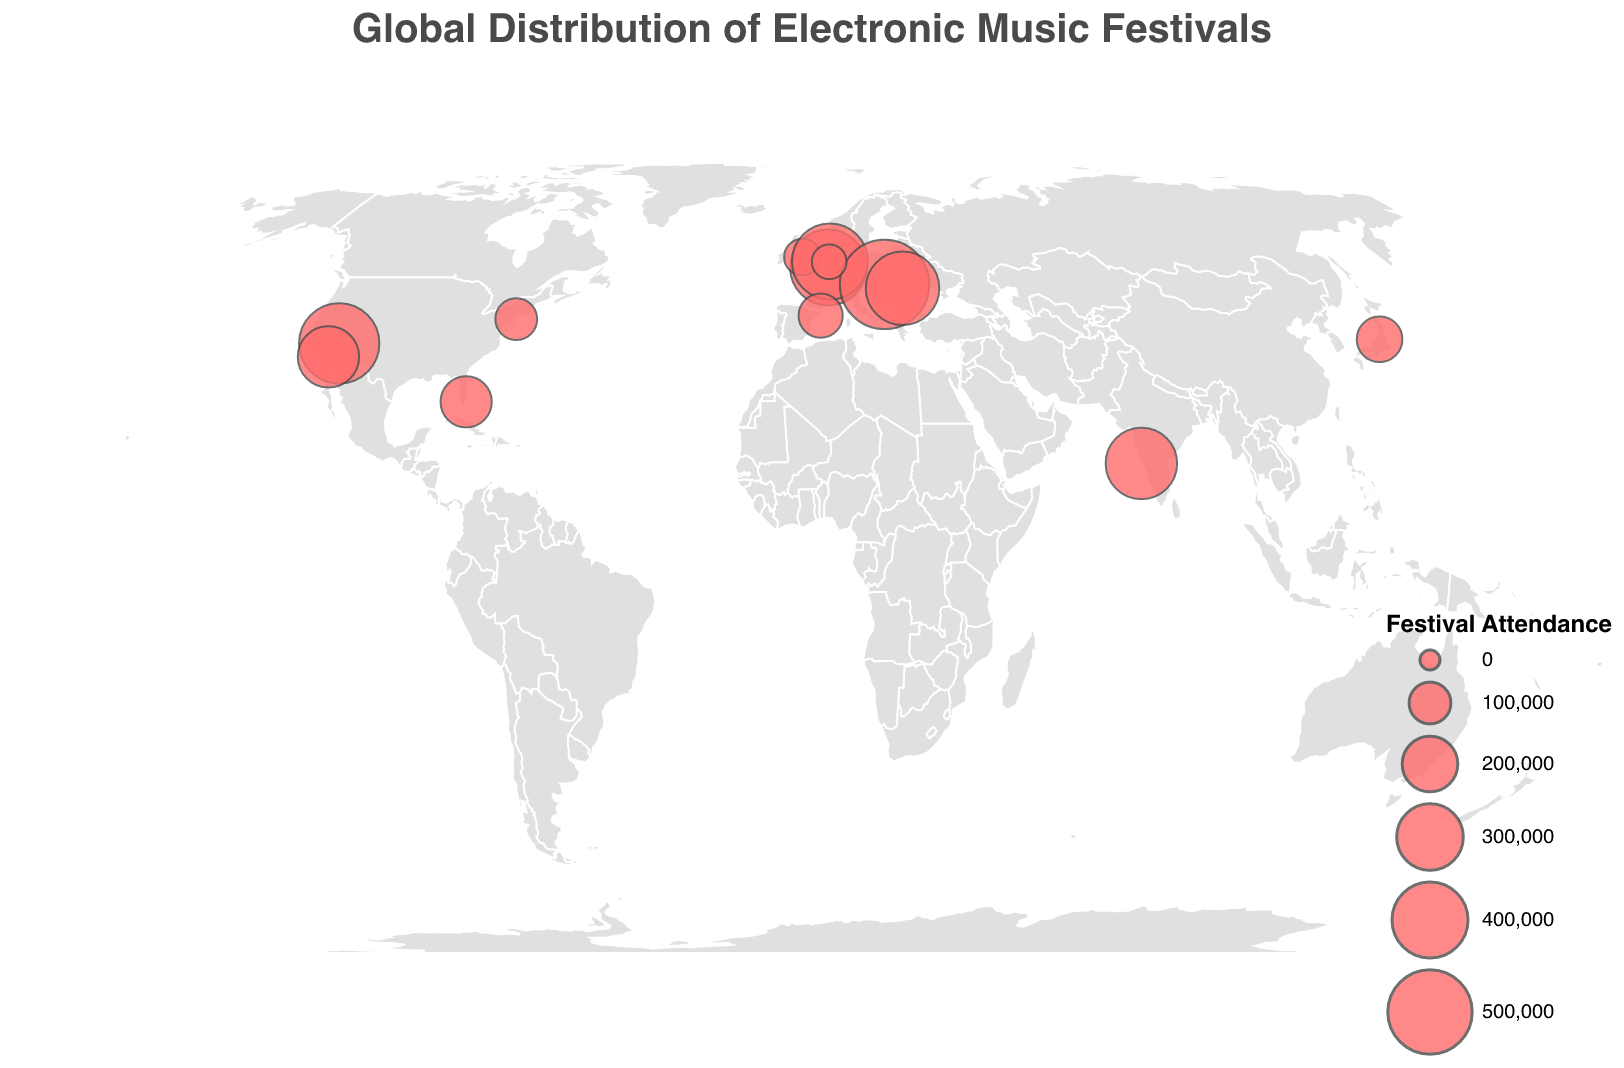Which festival has the highest attendance? By looking at the size of the circles, we identify that Sziget Festival in Budapest, Hungary, has the largest circle, indicating the highest attendance of 565,000.
Answer: Sziget Festival in Budapest, Hungary Which country has the most festivals listed in the figure? From the tooltip information, the USA has the most festivals listed with four: Ultra Music Festival, Electric Daisy Carnival, Coachella, and Electric Zoo.
Answer: USA What is the total attendance of festivals in the Netherlands? There are two festivals in the Netherlands: Amsterdam Dance Event (400,000) and Mysteryland (60,000). Summing these gives 400,000 + 60,000 = 460,000.
Answer: 460,000 Which festival is located farthest east? Reviewing the longitudes, the farthest east festival is Fuji Rock Festival in Yuzawa, Japan, with a longitude of 138.8167.
Answer: Fuji Rock Festival in Yuzawa, Japan Compare the attendance figures of Tomorrowland and Sunburn Festival. Which one has higher attendance? Tomorrowland has an attendance of 400,000, while Sunburn Festival has 350,000. Since 400,000 is greater than 350,000, Tomorrowland has higher attendance.
Answer: Tomorrowland Which festival has the smallest attendance, and what is its figure? Mysteryland in Haarlemmermeer, Netherlands has the smallest attendance with 60,000 attendees.
Answer: Mysteryland in Haarlemmermeer, Netherlands with 60,000 attendees How many festivals have an attendance of more than 300,000? Reviewing the data, we find five festivals with over 300,000 attendees: Tomorrowland (400,000), Electric Daisy Carnival (450,000), Sunburn Festival (350,000), Sziget Festival (565,000), and Untold Festival (372,000).
Answer: 5 What is the average attendance for all festivals listed? Summing all attendances: 400,000 + 165,000 + 450,000 + 70,000 + 350,000 + 400,000 + 565,000 + 372,000 + 125,000 + 115,000 + 250,000 + 100,000 + 60,000 = 3,422,000. There are 13 festivals, so the average is 3,422,000 / 13 ≈ 263,231.
Answer: Approximately 263,231 Which festival is located closest to the equator (latitude 0)? Goa, India, at 15.2993° is the closest festival to the equator (Sunburn Festival).
Answer: Sunburn Festival in Goa, India Are there more festivals in Europe or the USA based on this data? Europe has six festivals: Tomorrowland (Belgium), Creamfields (UK), Amsterdam Dance Event and Mysteryland (Netherlands), Sziget Festival (Hungary), Untold Festival (Romania), and Sónar (Spain). The USA has four festivals: Ultra Music Festival, Electric Daisy Carnival, Coachella, and Electric Zoo. Clearly, Europe has more festivals listed.
Answer: Europe 